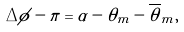<formula> <loc_0><loc_0><loc_500><loc_500>\Delta \phi - \pi = \alpha - \theta _ { m } - \overline { \theta } _ { m } ,</formula> 